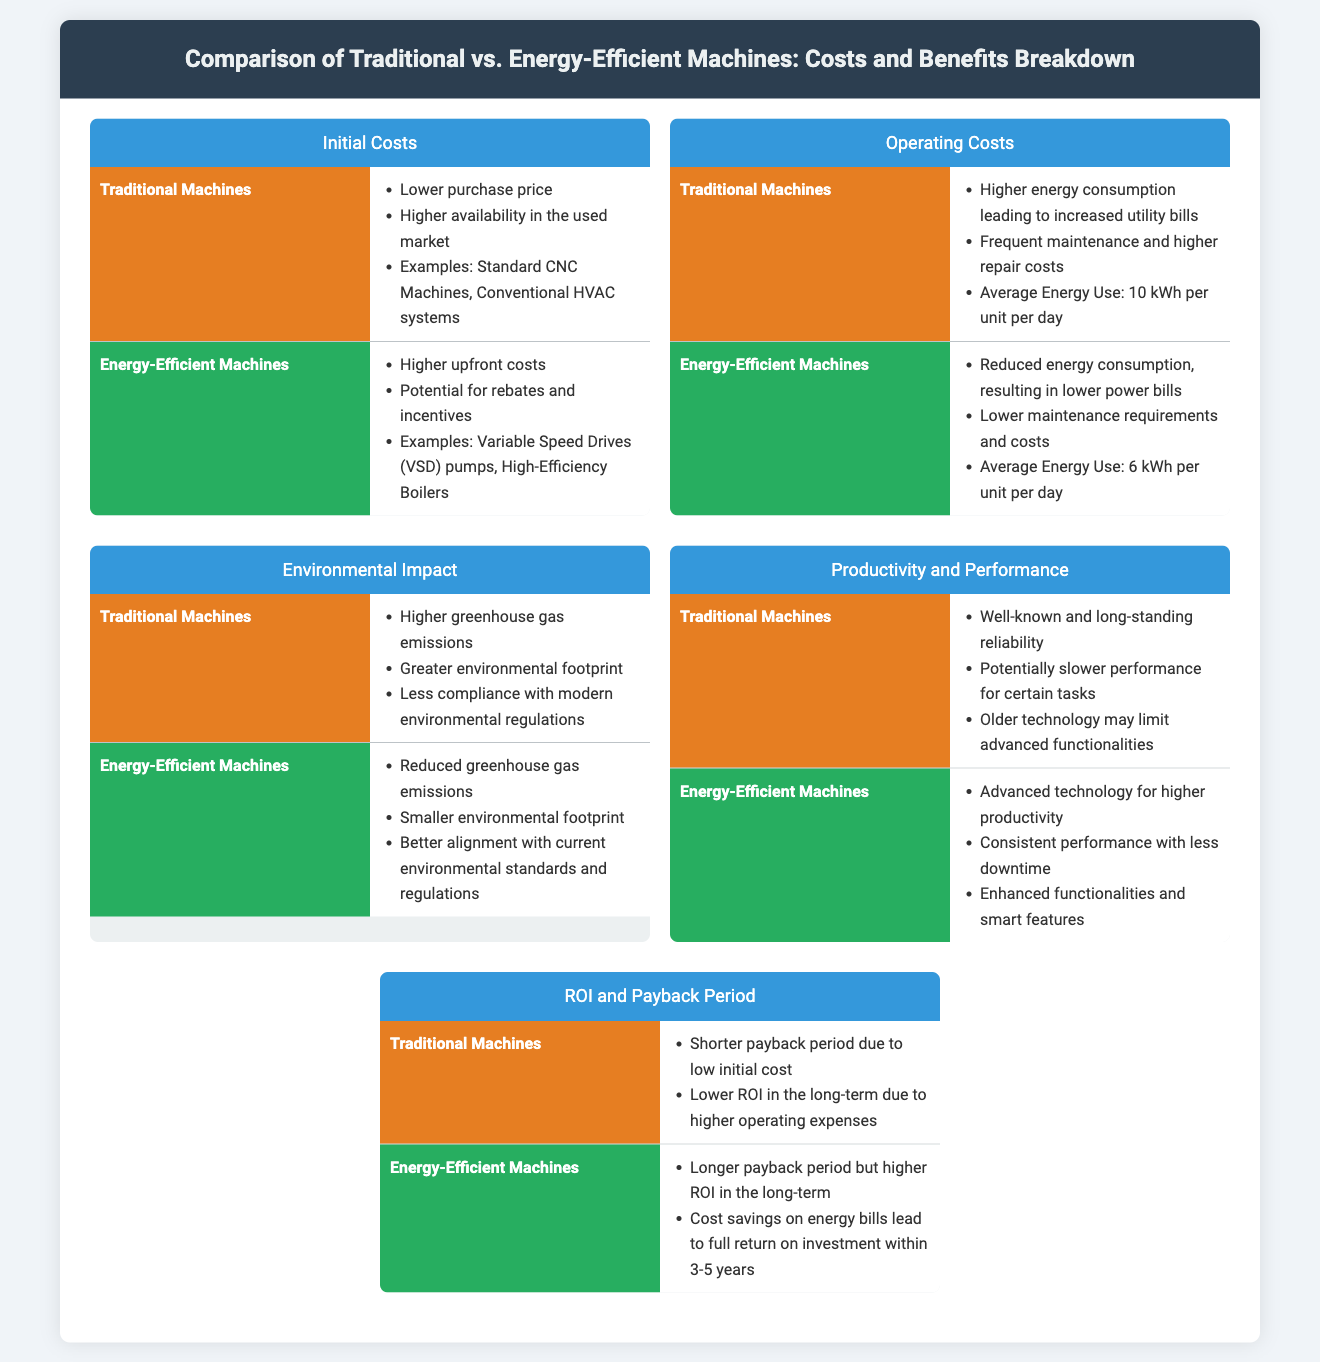what are traditional machines typically known for? Traditional machines are known for their well-known and long-standing reliability, which is highlighted in the document.
Answer: well-known reliability what is the average energy use of energy-efficient machines? The document states that the average energy use for energy-efficient machines is 6 kWh per unit per day.
Answer: 6 kWh per unit per day what do energy-efficient machines offer in terms of operating costs compared to traditional machines? Energy-efficient machines have reduced energy consumption resulting in lower power bills compared to traditional machines, according to the infographic.
Answer: lower power bills what is an example of a traditional machine? The document lists standard CNC machines as an example of traditional machines.
Answer: Standard CNC Machines how does the payback period for energy-efficient machines compare to traditional machines? The payback period for energy-efficient machines is longer, but they offer higher ROI in the long-term, which is explained in the infographic.
Answer: longer payback period how might the environmental impact of traditional machines be described? Traditional machines are associated with higher greenhouse gas emissions and a greater environmental footprint as stated in the document.
Answer: higher greenhouse gas emissions what are the initial costs of energy-efficient machines generally described as? The initial costs of energy-efficient machines are described as higher upfront costs in the infographic.
Answer: higher upfront costs what is one benefit of energy-efficient machines concerning maintenance? Energy-efficient machines have lower maintenance requirements and costs compared to traditional machines, mentioned in the document.
Answer: lower maintenance requirements what is the relationship between initial costs and ROI for traditional machines? Traditional machines have a shorter payback period due to low initial cost, leading to lower ROI in the long-term per the data in the document.
Answer: shorter payback period 